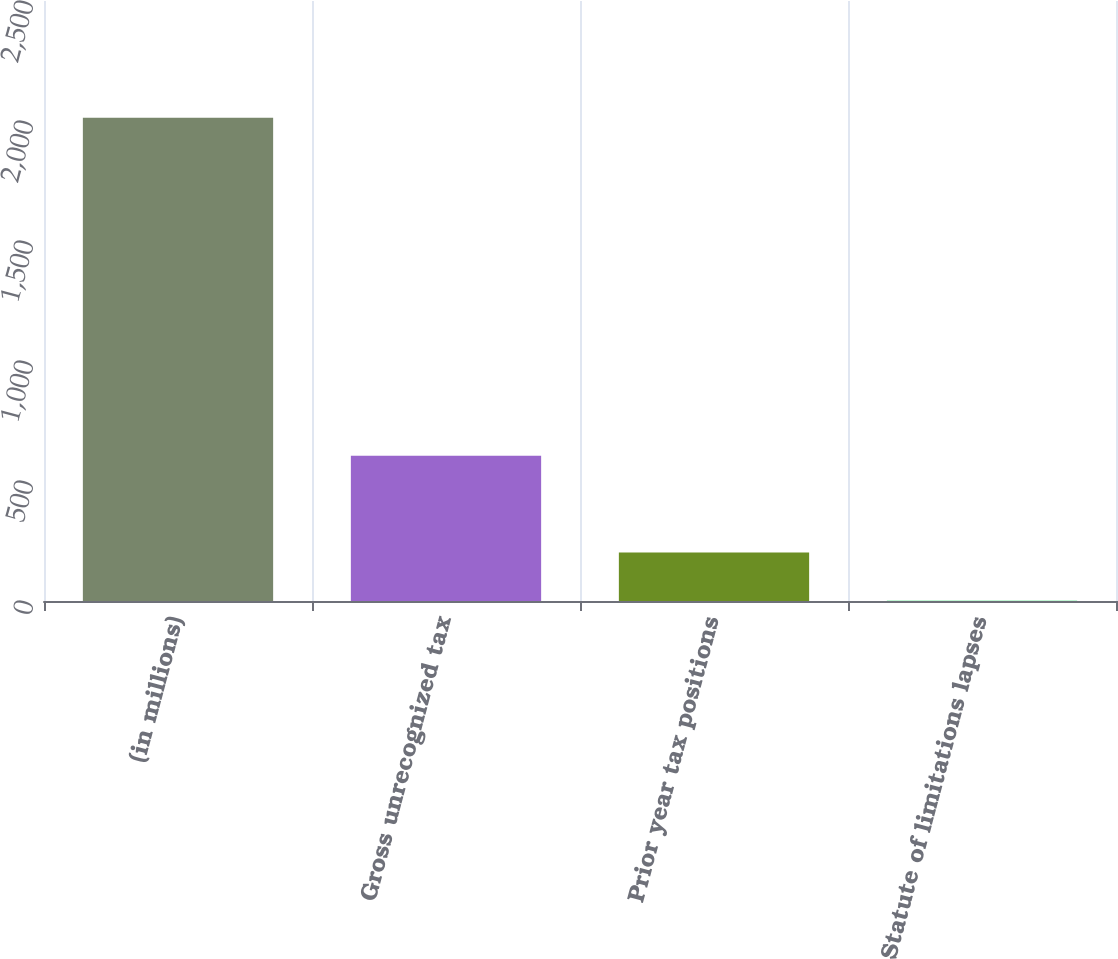Convert chart. <chart><loc_0><loc_0><loc_500><loc_500><bar_chart><fcel>(in millions)<fcel>Gross unrecognized tax<fcel>Prior year tax positions<fcel>Statute of limitations lapses<nl><fcel>2014<fcel>604.9<fcel>202.3<fcel>1<nl></chart> 